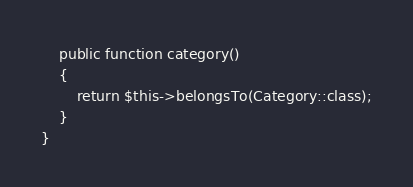<code> <loc_0><loc_0><loc_500><loc_500><_PHP_>    public function category()
    {
        return $this->belongsTo(Category::class);
    }
}
</code> 